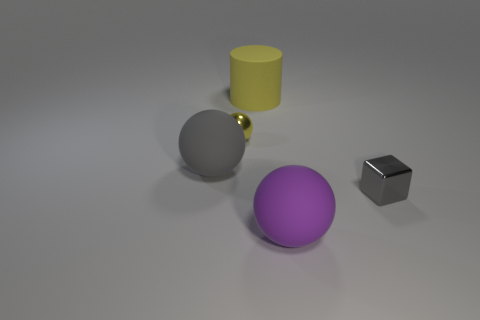Add 5 big brown matte cylinders. How many objects exist? 10 Subtract all cubes. How many objects are left? 4 Subtract 1 purple spheres. How many objects are left? 4 Subtract all small blue matte spheres. Subtract all tiny shiny cubes. How many objects are left? 4 Add 4 spheres. How many spheres are left? 7 Add 1 metallic cubes. How many metallic cubes exist? 2 